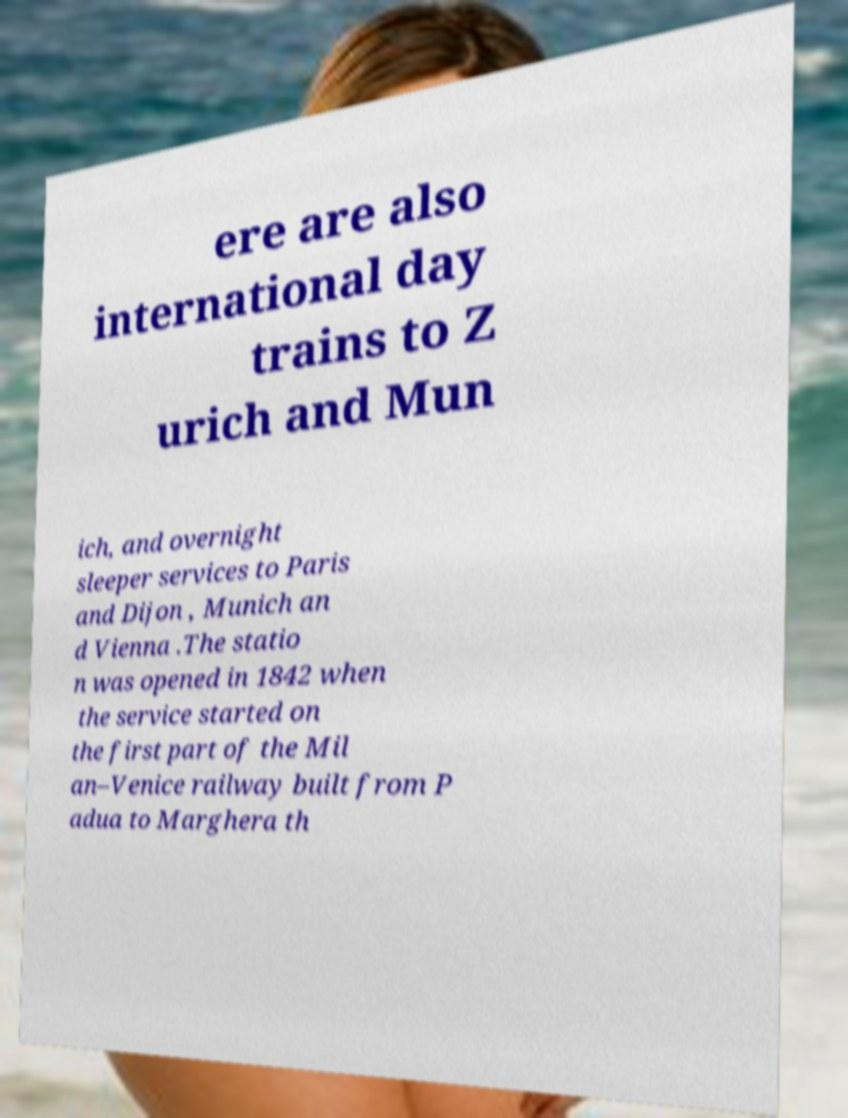Please identify and transcribe the text found in this image. ere are also international day trains to Z urich and Mun ich, and overnight sleeper services to Paris and Dijon , Munich an d Vienna .The statio n was opened in 1842 when the service started on the first part of the Mil an–Venice railway built from P adua to Marghera th 